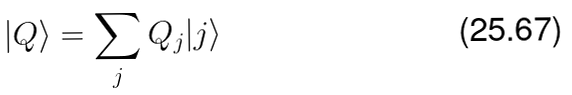<formula> <loc_0><loc_0><loc_500><loc_500>| Q \rangle = \sum _ { j } Q _ { j } | j \rangle</formula> 